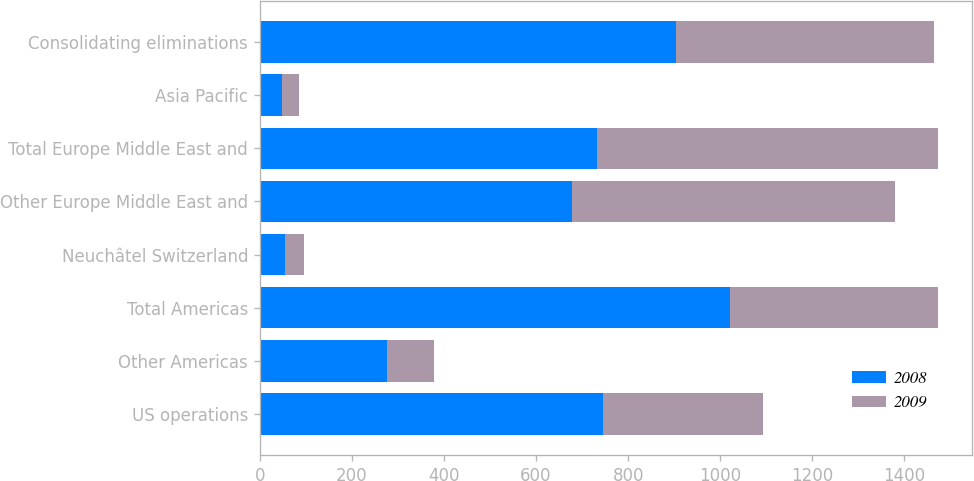<chart> <loc_0><loc_0><loc_500><loc_500><stacked_bar_chart><ecel><fcel>US operations<fcel>Other Americas<fcel>Total Americas<fcel>Neuchâtel Switzerland<fcel>Other Europe Middle East and<fcel>Total Europe Middle East and<fcel>Asia Pacific<fcel>Consolidating eliminations<nl><fcel>2008<fcel>744.3<fcel>276.7<fcel>1021<fcel>55.3<fcel>677.9<fcel>733.2<fcel>48.7<fcel>903.5<nl><fcel>2009<fcel>349.3<fcel>102.1<fcel>451.4<fcel>40<fcel>700.5<fcel>740.5<fcel>36.4<fcel>560.9<nl></chart> 